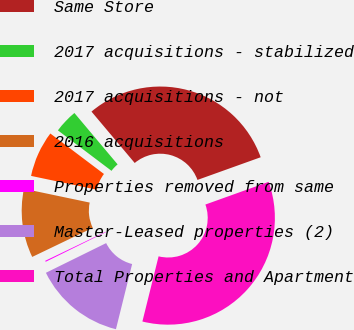<chart> <loc_0><loc_0><loc_500><loc_500><pie_chart><fcel>Same Store<fcel>2017 acquisitions - stabilized<fcel>2017 acquisitions - not<fcel>2016 acquisitions<fcel>Properties removed from same<fcel>Master-Leased properties (2)<fcel>Total Properties and Apartment<nl><fcel>30.65%<fcel>3.58%<fcel>7.0%<fcel>10.42%<fcel>0.16%<fcel>13.84%<fcel>34.36%<nl></chart> 